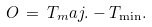Convert formula to latex. <formula><loc_0><loc_0><loc_500><loc_500>O \, = \, T _ { m } a j . - T _ { \min } .</formula> 